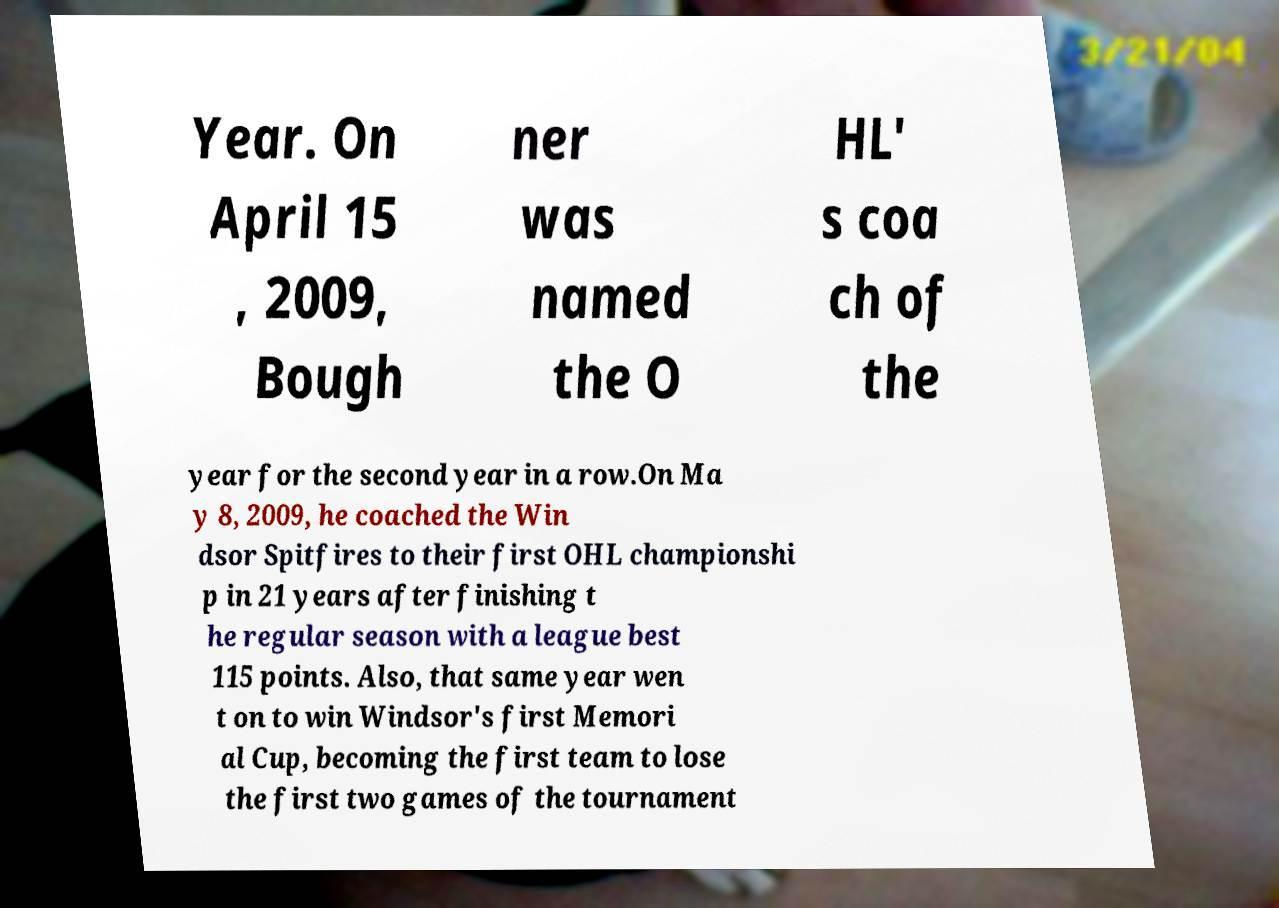Please identify and transcribe the text found in this image. Year. On April 15 , 2009, Bough ner was named the O HL' s coa ch of the year for the second year in a row.On Ma y 8, 2009, he coached the Win dsor Spitfires to their first OHL championshi p in 21 years after finishing t he regular season with a league best 115 points. Also, that same year wen t on to win Windsor's first Memori al Cup, becoming the first team to lose the first two games of the tournament 